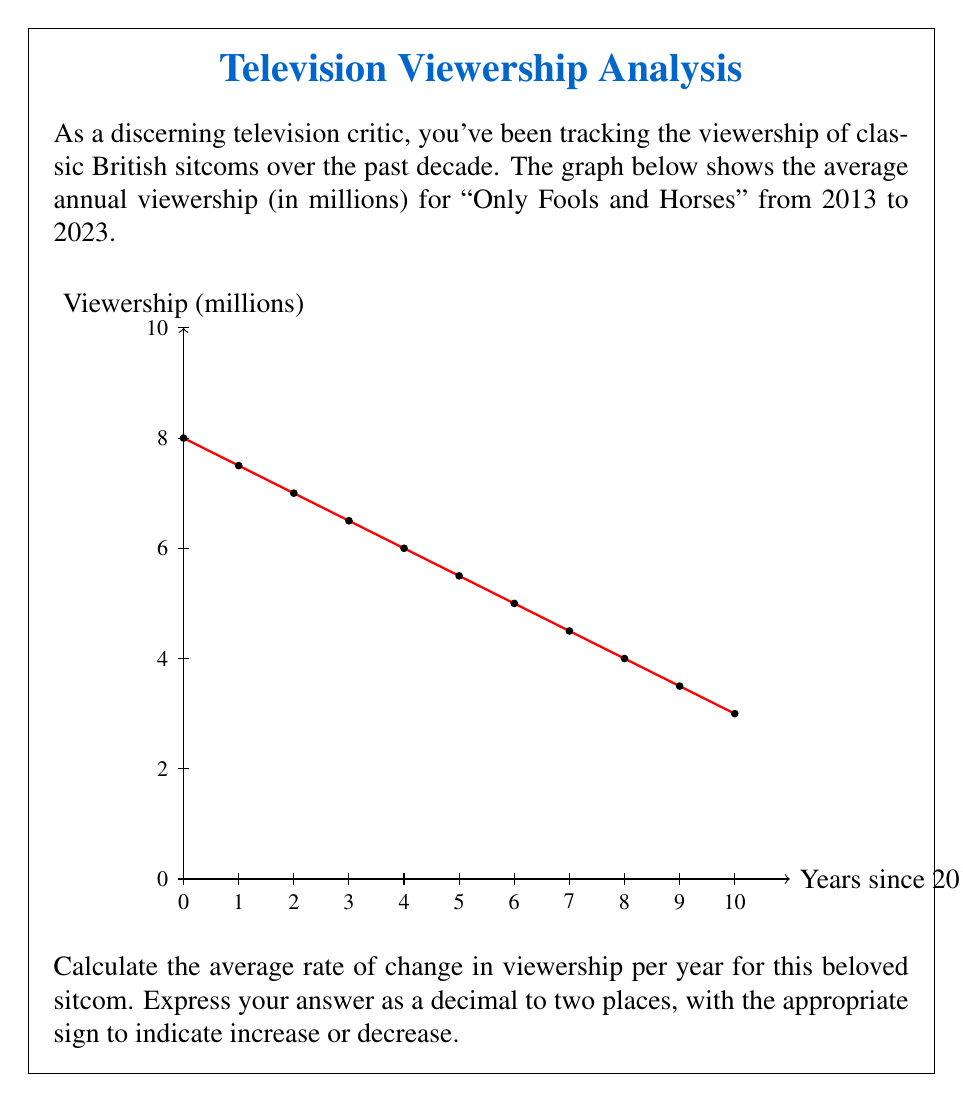Show me your answer to this math problem. To calculate the average rate of change in viewership, we need to determine the change in viewership over the entire period and divide it by the number of years.

Step 1: Identify the viewership at the start and end points.
- In 2013 (x = 0): y = 8 million viewers
- In 2023 (x = 10): y = 3 million viewers

Step 2: Calculate the total change in viewership.
Change in viewership = Final viewership - Initial viewership
$$\Delta y = 3 - 8 = -5$$ million viewers

Step 3: Determine the time period.
Time period = 10 years

Step 4: Calculate the average rate of change.
Average rate of change = Change in viewership ÷ Time period
$$\frac{\Delta y}{\Delta x} = \frac{-5}{10} = -0.5$$ million viewers per year

Step 5: Express the answer to two decimal places.
-0.50 million viewers per year

The negative sign indicates a decrease in viewership over time.
Answer: -0.50 